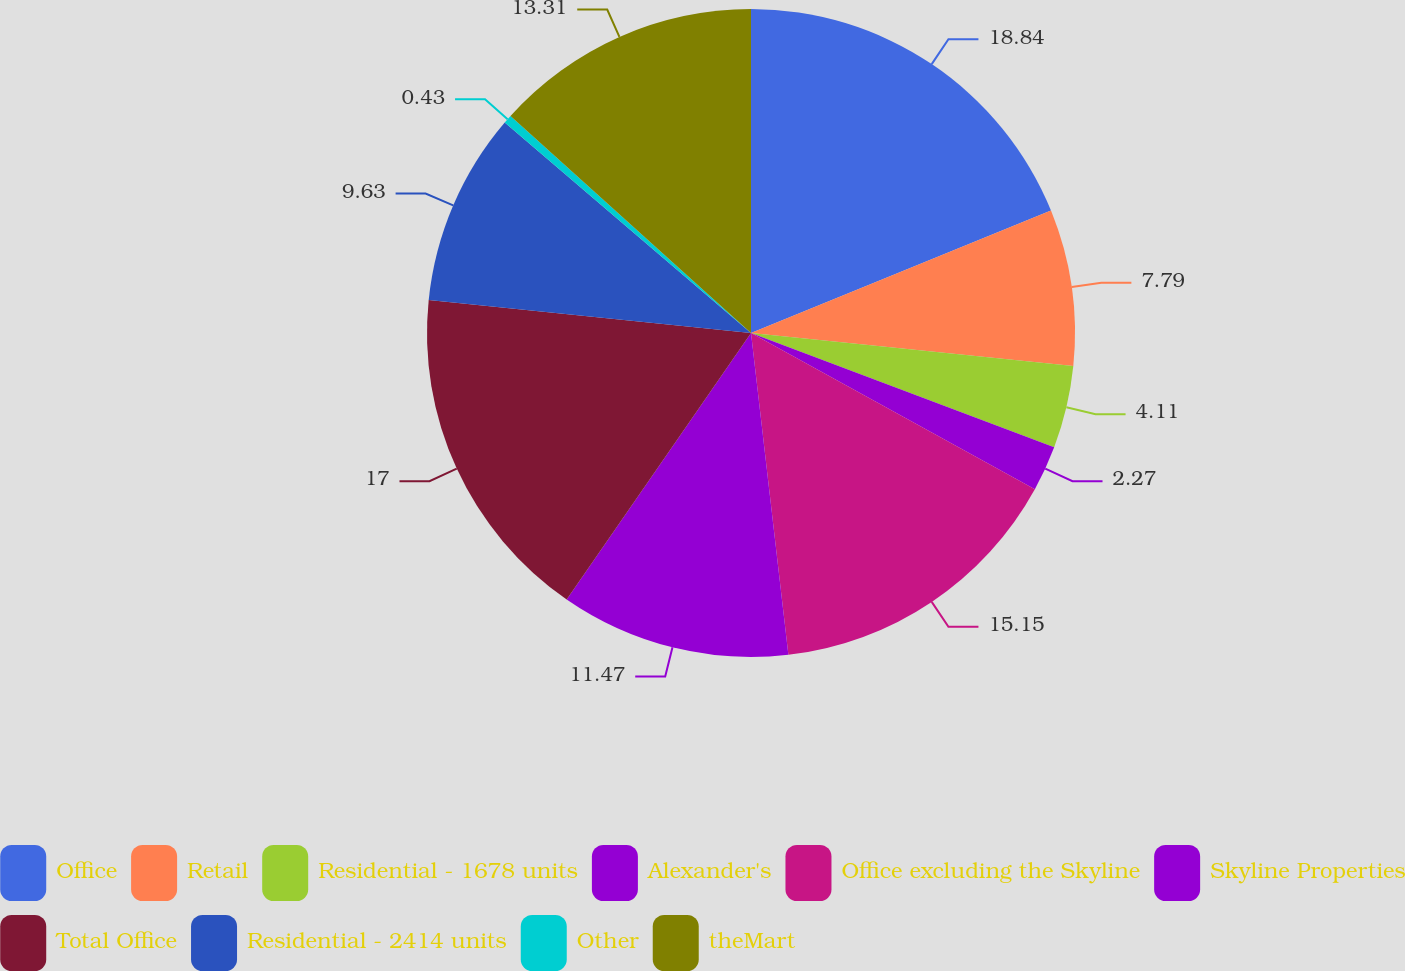<chart> <loc_0><loc_0><loc_500><loc_500><pie_chart><fcel>Office<fcel>Retail<fcel>Residential - 1678 units<fcel>Alexander's<fcel>Office excluding the Skyline<fcel>Skyline Properties<fcel>Total Office<fcel>Residential - 2414 units<fcel>Other<fcel>theMart<nl><fcel>18.83%<fcel>7.79%<fcel>4.11%<fcel>2.27%<fcel>15.15%<fcel>11.47%<fcel>16.99%<fcel>9.63%<fcel>0.43%<fcel>13.31%<nl></chart> 